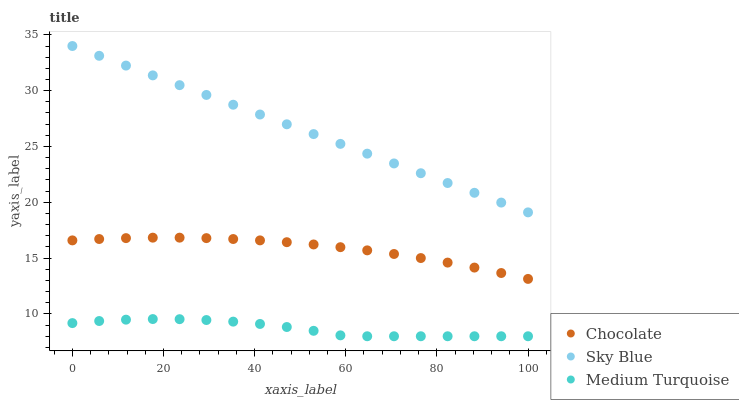Does Medium Turquoise have the minimum area under the curve?
Answer yes or no. Yes. Does Sky Blue have the maximum area under the curve?
Answer yes or no. Yes. Does Chocolate have the minimum area under the curve?
Answer yes or no. No. Does Chocolate have the maximum area under the curve?
Answer yes or no. No. Is Sky Blue the smoothest?
Answer yes or no. Yes. Is Medium Turquoise the roughest?
Answer yes or no. Yes. Is Chocolate the smoothest?
Answer yes or no. No. Is Chocolate the roughest?
Answer yes or no. No. Does Medium Turquoise have the lowest value?
Answer yes or no. Yes. Does Chocolate have the lowest value?
Answer yes or no. No. Does Sky Blue have the highest value?
Answer yes or no. Yes. Does Chocolate have the highest value?
Answer yes or no. No. Is Chocolate less than Sky Blue?
Answer yes or no. Yes. Is Sky Blue greater than Medium Turquoise?
Answer yes or no. Yes. Does Chocolate intersect Sky Blue?
Answer yes or no. No. 